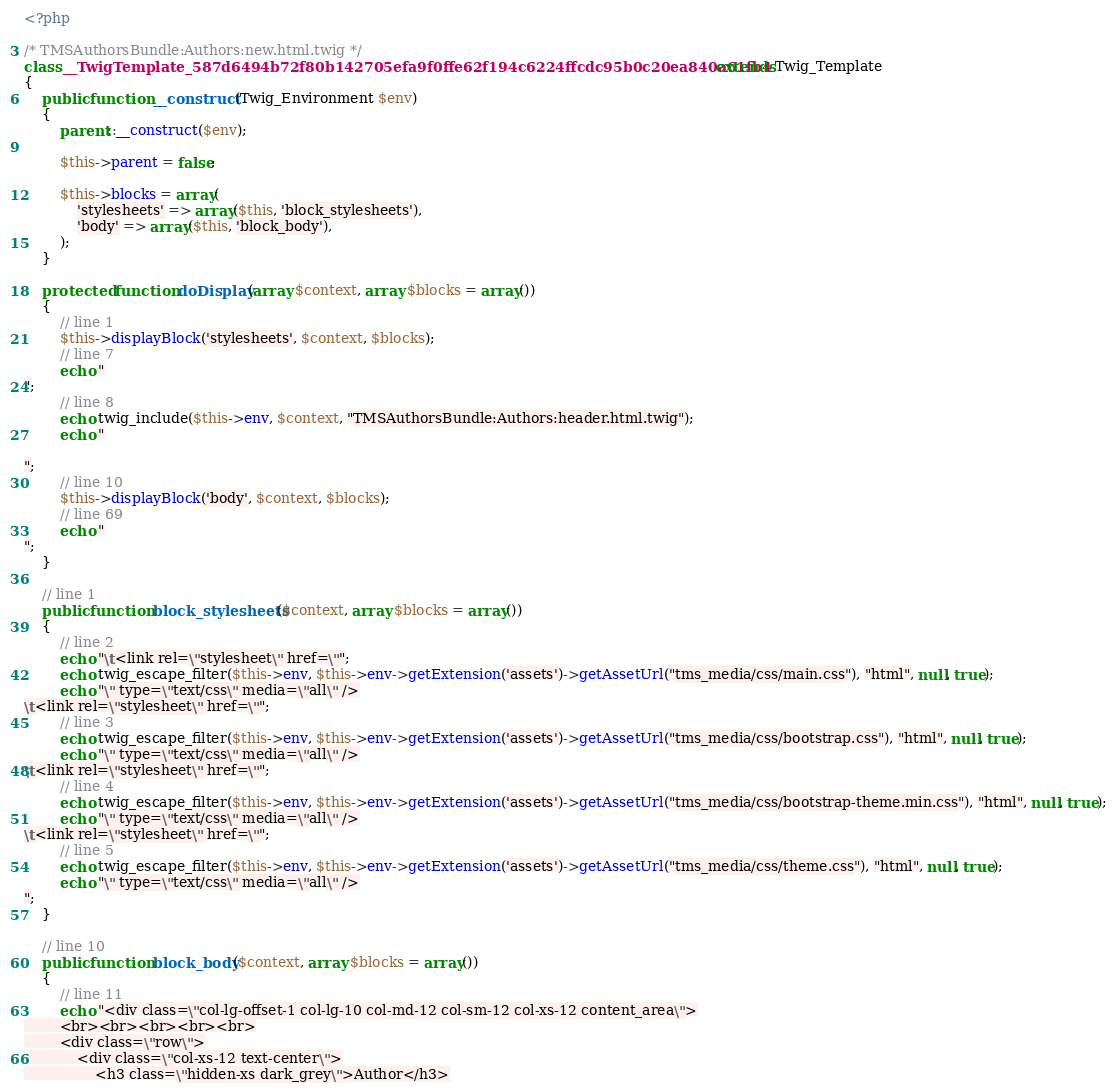Convert code to text. <code><loc_0><loc_0><loc_500><loc_500><_PHP_><?php

/* TMSAuthorsBundle:Authors:new.html.twig */
class __TwigTemplate_587d6494b72f80b142705efa9f0ffe62f194c6224ffcdc95b0c20ea840a61fb4 extends Twig_Template
{
    public function __construct(Twig_Environment $env)
    {
        parent::__construct($env);

        $this->parent = false;

        $this->blocks = array(
            'stylesheets' => array($this, 'block_stylesheets'),
            'body' => array($this, 'block_body'),
        );
    }

    protected function doDisplay(array $context, array $blocks = array())
    {
        // line 1
        $this->displayBlock('stylesheets', $context, $blocks);
        // line 7
        echo "
";
        // line 8
        echo twig_include($this->env, $context, "TMSAuthorsBundle:Authors:header.html.twig");
        echo "

";
        // line 10
        $this->displayBlock('body', $context, $blocks);
        // line 69
        echo "
";
    }

    // line 1
    public function block_stylesheets($context, array $blocks = array())
    {
        // line 2
        echo "\t<link rel=\"stylesheet\" href=\"";
        echo twig_escape_filter($this->env, $this->env->getExtension('assets')->getAssetUrl("tms_media/css/main.css"), "html", null, true);
        echo "\" type=\"text/css\" media=\"all\" />
\t<link rel=\"stylesheet\" href=\"";
        // line 3
        echo twig_escape_filter($this->env, $this->env->getExtension('assets')->getAssetUrl("tms_media/css/bootstrap.css"), "html", null, true);
        echo "\" type=\"text/css\" media=\"all\" />
\t<link rel=\"stylesheet\" href=\"";
        // line 4
        echo twig_escape_filter($this->env, $this->env->getExtension('assets')->getAssetUrl("tms_media/css/bootstrap-theme.min.css"), "html", null, true);
        echo "\" type=\"text/css\" media=\"all\" />
\t<link rel=\"stylesheet\" href=\"";
        // line 5
        echo twig_escape_filter($this->env, $this->env->getExtension('assets')->getAssetUrl("tms_media/css/theme.css"), "html", null, true);
        echo "\" type=\"text/css\" media=\"all\" />
";
    }

    // line 10
    public function block_body($context, array $blocks = array())
    {
        // line 11
        echo "<div class=\"col-lg-offset-1 col-lg-10 col-md-12 col-sm-12 col-xs-12 content_area\">
        <br><br><br><br><br>
        <div class=\"row\">
            <div class=\"col-xs-12 text-center\">
                <h3 class=\"hidden-xs dark_grey\">Author</h3></code> 